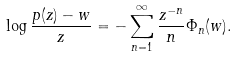<formula> <loc_0><loc_0><loc_500><loc_500>\log \frac { p ( z ) - w } { z } = - \sum _ { n = 1 } ^ { \infty } \frac { z ^ { - n } } { n } \Phi _ { n } ( w ) .</formula> 